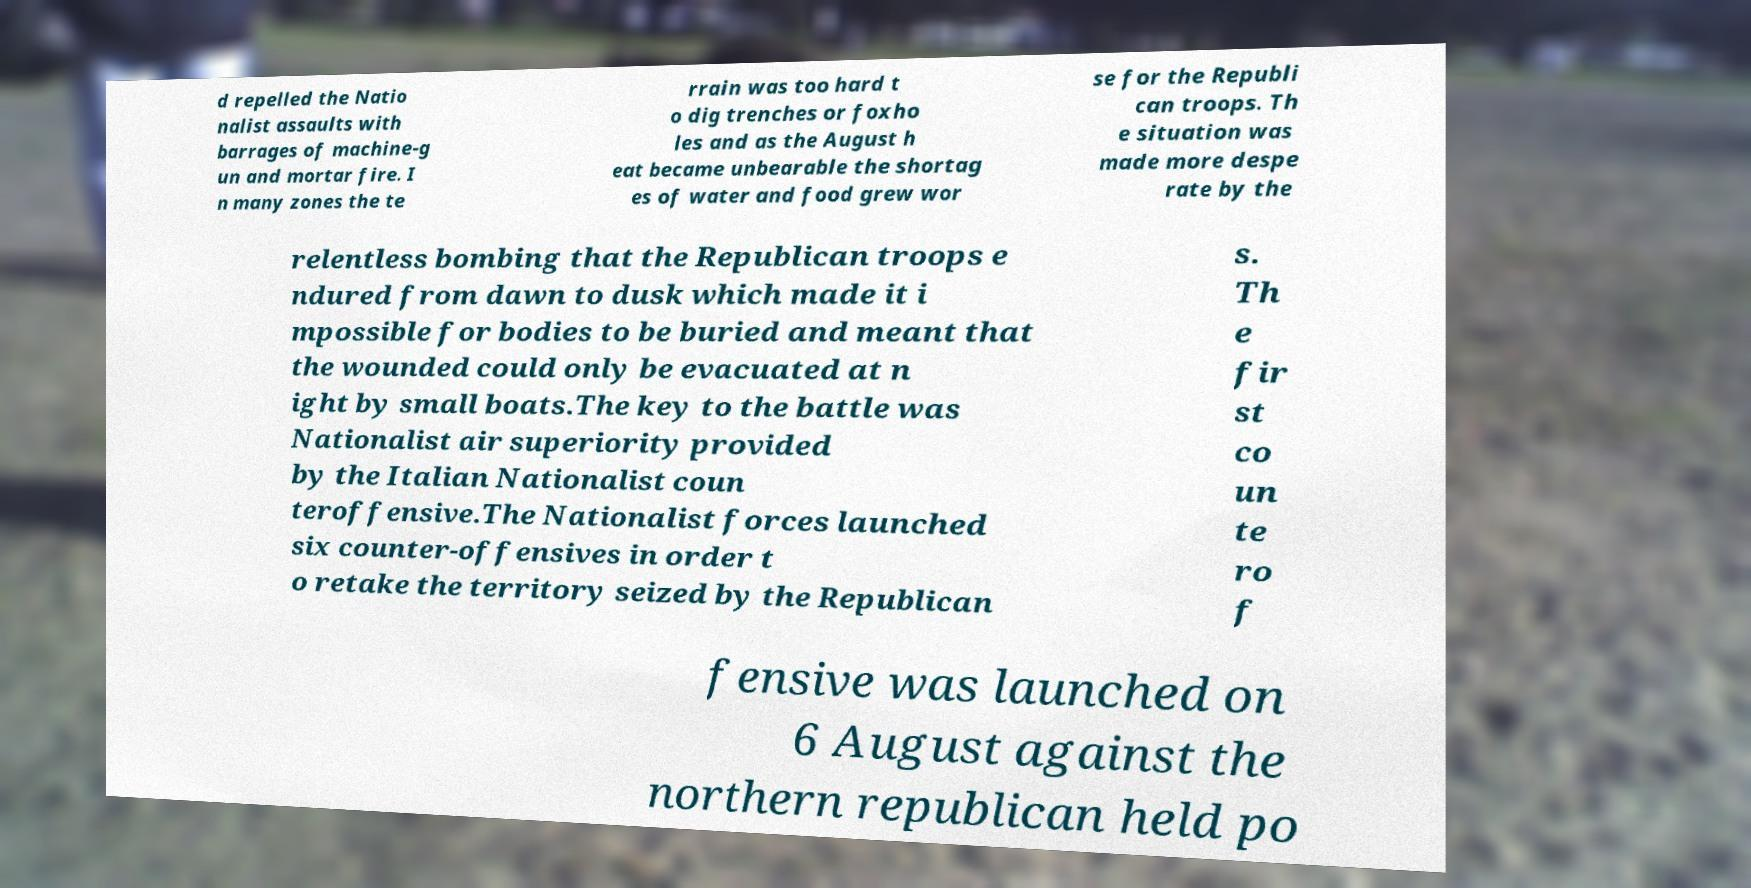There's text embedded in this image that I need extracted. Can you transcribe it verbatim? d repelled the Natio nalist assaults with barrages of machine-g un and mortar fire. I n many zones the te rrain was too hard t o dig trenches or foxho les and as the August h eat became unbearable the shortag es of water and food grew wor se for the Republi can troops. Th e situation was made more despe rate by the relentless bombing that the Republican troops e ndured from dawn to dusk which made it i mpossible for bodies to be buried and meant that the wounded could only be evacuated at n ight by small boats.The key to the battle was Nationalist air superiority provided by the Italian Nationalist coun teroffensive.The Nationalist forces launched six counter-offensives in order t o retake the territory seized by the Republican s. Th e fir st co un te ro f fensive was launched on 6 August against the northern republican held po 